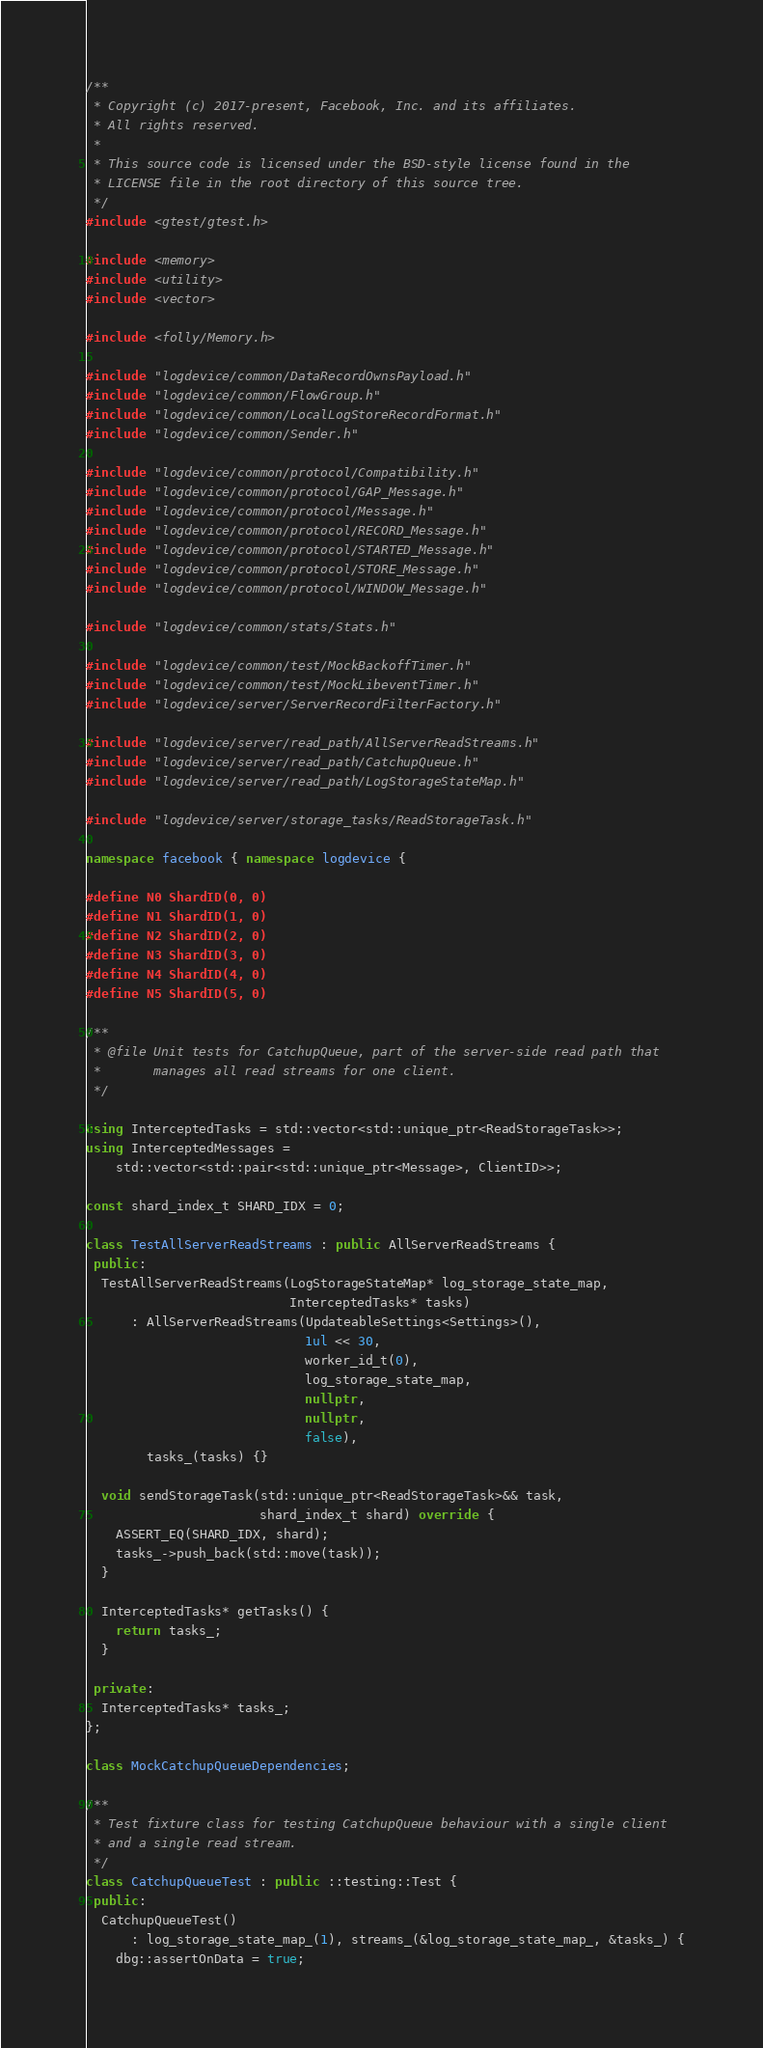<code> <loc_0><loc_0><loc_500><loc_500><_C++_>/**
 * Copyright (c) 2017-present, Facebook, Inc. and its affiliates.
 * All rights reserved.
 *
 * This source code is licensed under the BSD-style license found in the
 * LICENSE file in the root directory of this source tree.
 */
#include <gtest/gtest.h>

#include <memory>
#include <utility>
#include <vector>

#include <folly/Memory.h>

#include "logdevice/common/DataRecordOwnsPayload.h"
#include "logdevice/common/FlowGroup.h"
#include "logdevice/common/LocalLogStoreRecordFormat.h"
#include "logdevice/common/Sender.h"

#include "logdevice/common/protocol/Compatibility.h"
#include "logdevice/common/protocol/GAP_Message.h"
#include "logdevice/common/protocol/Message.h"
#include "logdevice/common/protocol/RECORD_Message.h"
#include "logdevice/common/protocol/STARTED_Message.h"
#include "logdevice/common/protocol/STORE_Message.h"
#include "logdevice/common/protocol/WINDOW_Message.h"

#include "logdevice/common/stats/Stats.h"

#include "logdevice/common/test/MockBackoffTimer.h"
#include "logdevice/common/test/MockLibeventTimer.h"
#include "logdevice/server/ServerRecordFilterFactory.h"

#include "logdevice/server/read_path/AllServerReadStreams.h"
#include "logdevice/server/read_path/CatchupQueue.h"
#include "logdevice/server/read_path/LogStorageStateMap.h"

#include "logdevice/server/storage_tasks/ReadStorageTask.h"

namespace facebook { namespace logdevice {

#define N0 ShardID(0, 0)
#define N1 ShardID(1, 0)
#define N2 ShardID(2, 0)
#define N3 ShardID(3, 0)
#define N4 ShardID(4, 0)
#define N5 ShardID(5, 0)

/**
 * @file Unit tests for CatchupQueue, part of the server-side read path that
 *       manages all read streams for one client.
 */

using InterceptedTasks = std::vector<std::unique_ptr<ReadStorageTask>>;
using InterceptedMessages =
    std::vector<std::pair<std::unique_ptr<Message>, ClientID>>;

const shard_index_t SHARD_IDX = 0;

class TestAllServerReadStreams : public AllServerReadStreams {
 public:
  TestAllServerReadStreams(LogStorageStateMap* log_storage_state_map,
                           InterceptedTasks* tasks)
      : AllServerReadStreams(UpdateableSettings<Settings>(),
                             1ul << 30,
                             worker_id_t(0),
                             log_storage_state_map,
                             nullptr,
                             nullptr,
                             false),
        tasks_(tasks) {}

  void sendStorageTask(std::unique_ptr<ReadStorageTask>&& task,
                       shard_index_t shard) override {
    ASSERT_EQ(SHARD_IDX, shard);
    tasks_->push_back(std::move(task));
  }

  InterceptedTasks* getTasks() {
    return tasks_;
  }

 private:
  InterceptedTasks* tasks_;
};

class MockCatchupQueueDependencies;

/**
 * Test fixture class for testing CatchupQueue behaviour with a single client
 * and a single read stream.
 */
class CatchupQueueTest : public ::testing::Test {
 public:
  CatchupQueueTest()
      : log_storage_state_map_(1), streams_(&log_storage_state_map_, &tasks_) {
    dbg::assertOnData = true;
</code> 